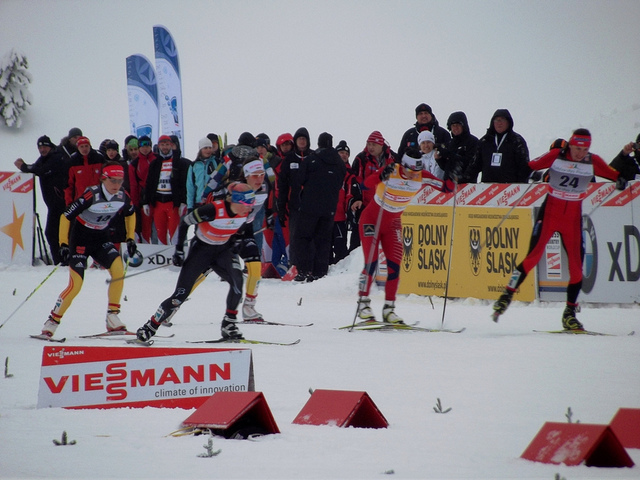Please transcribe the text information in this image. DOLNY DOLNY SLASK SLASK SS xDr xD 24 innovation climate MANN VIE 